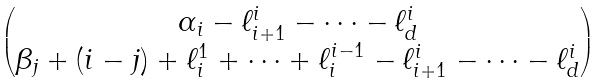<formula> <loc_0><loc_0><loc_500><loc_500>\begin{pmatrix} \alpha _ { i } - \ell _ { i + 1 } ^ { i } - \cdots - \ell _ { d } ^ { i } \\ \beta _ { j } + ( i - j ) + \ell _ { i } ^ { 1 } + \dots + \ell _ { i } ^ { i - 1 } - \ell _ { i + 1 } ^ { i } - \cdots - \ell _ { d } ^ { i } \end{pmatrix}</formula> 